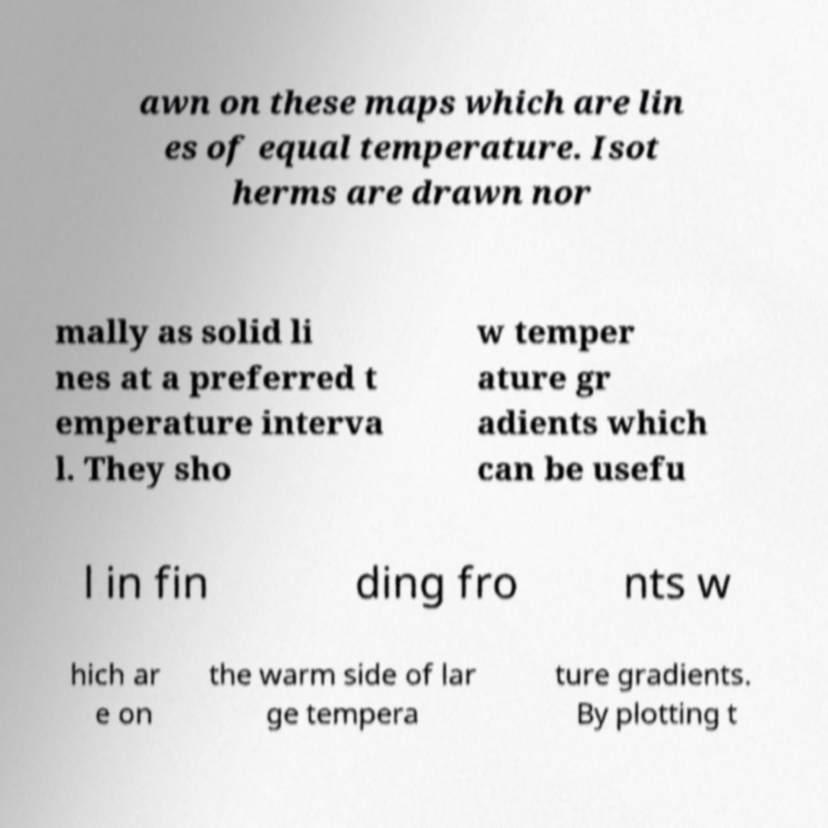Could you assist in decoding the text presented in this image and type it out clearly? awn on these maps which are lin es of equal temperature. Isot herms are drawn nor mally as solid li nes at a preferred t emperature interva l. They sho w temper ature gr adients which can be usefu l in fin ding fro nts w hich ar e on the warm side of lar ge tempera ture gradients. By plotting t 